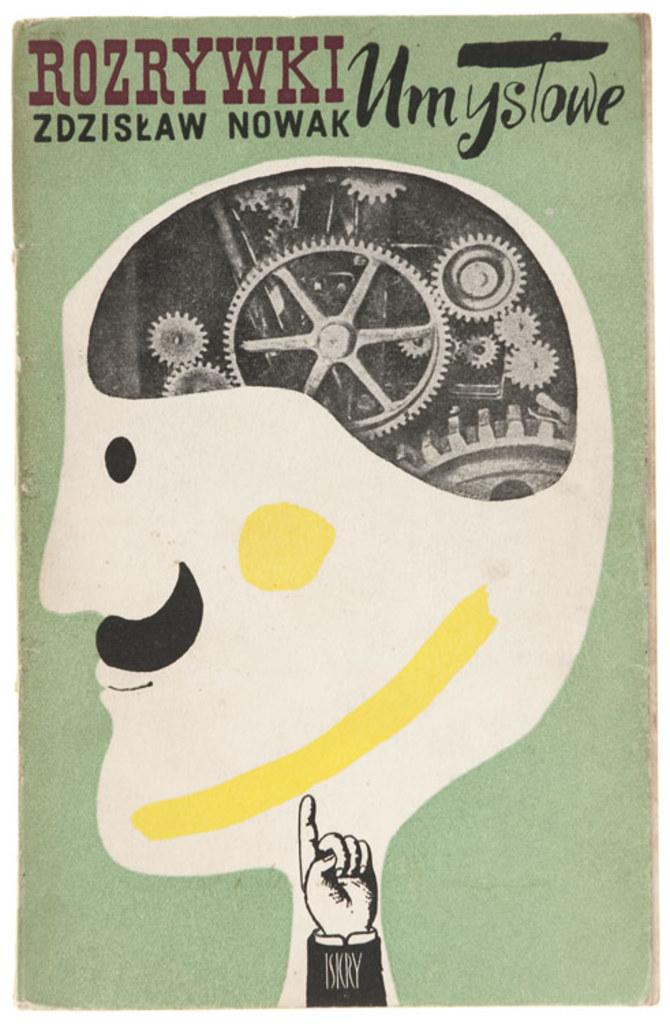Are threre gears in his head?
Keep it short and to the point. Answering does not require reading text in the image. What does the red word say?
Give a very brief answer. Rozrywki. 